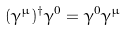Convert formula to latex. <formula><loc_0><loc_0><loc_500><loc_500>( \gamma ^ { \mu } ) ^ { \dagger } \gamma ^ { 0 } = \gamma ^ { 0 } \gamma ^ { \mu }</formula> 